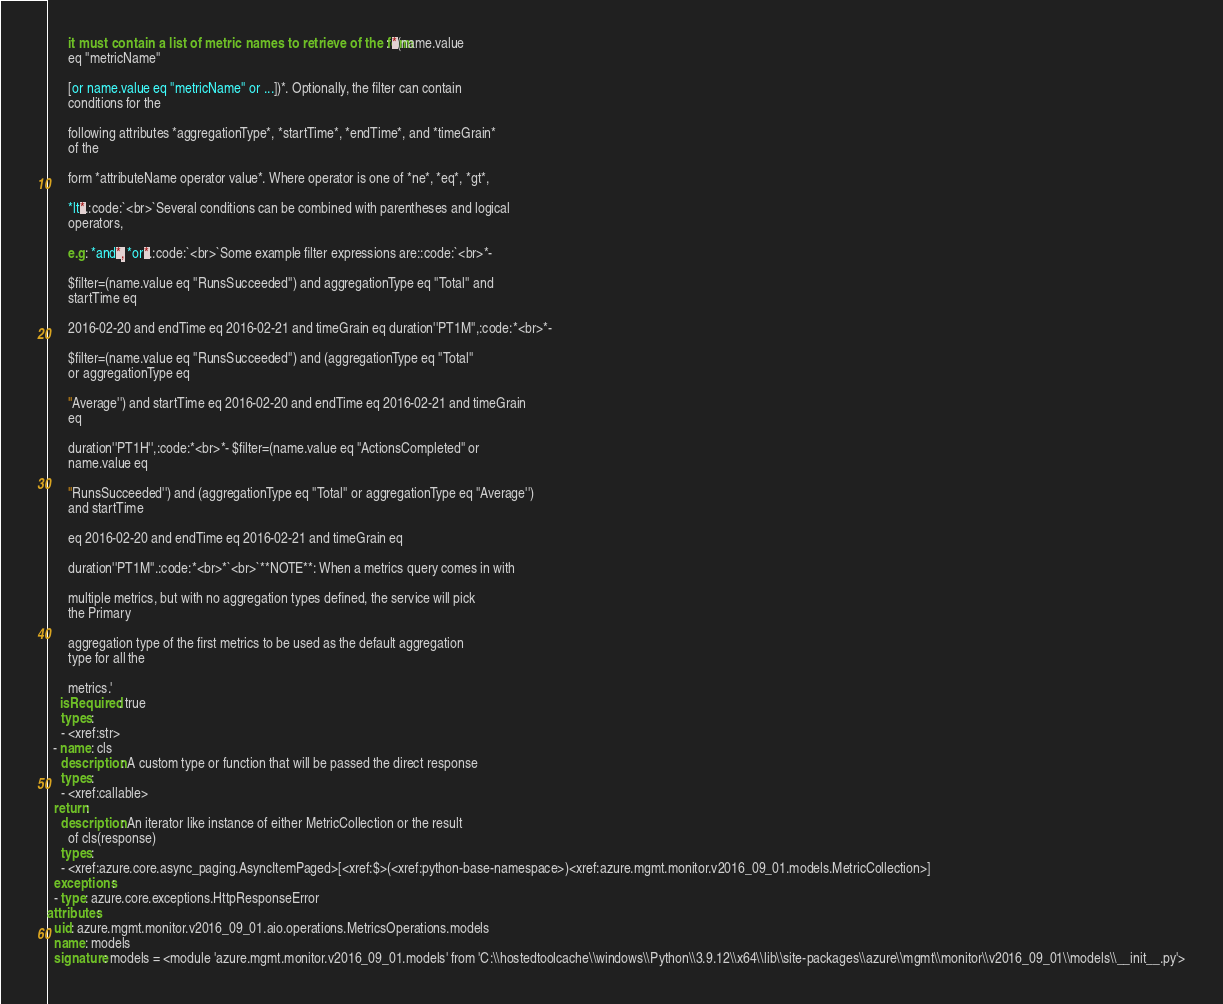Convert code to text. <code><loc_0><loc_0><loc_500><loc_500><_YAML_>      it must contain a list of metric names to retrieve of the form: *(name.value
      eq ''metricName''

      [or name.value eq ''metricName'' or ...])*. Optionally, the filter can contain
      conditions for the

      following attributes *aggregationType*, *startTime*, *endTime*, and *timeGrain*
      of the

      form *attributeName operator value*. Where operator is one of *ne*, *eq*, *gt*,

      *lt*.:code:`<br>`Several conditions can be combined with parentheses and logical
      operators,

      e.g: *and*, *or*.:code:`<br>`Some example filter expressions are::code:`<br>*-

      $filter=(name.value eq ''RunsSucceeded'') and aggregationType eq ''Total'' and
      startTime eq

      2016-02-20 and endTime eq 2016-02-21 and timeGrain eq duration''PT1M'',:code:*<br>*-

      $filter=(name.value eq ''RunsSucceeded'') and (aggregationType eq ''Total''
      or aggregationType eq

      ''Average'') and startTime eq 2016-02-20 and endTime eq 2016-02-21 and timeGrain
      eq

      duration''PT1H'',:code:*<br>*- $filter=(name.value eq ''ActionsCompleted'' or
      name.value eq

      ''RunsSucceeded'') and (aggregationType eq ''Total'' or aggregationType eq ''Average'')
      and startTime

      eq 2016-02-20 and endTime eq 2016-02-21 and timeGrain eq

      duration''PT1M''.:code:*<br>*`<br>`**NOTE**: When a metrics query comes in with

      multiple metrics, but with no aggregation types defined, the service will pick
      the Primary

      aggregation type of the first metrics to be used as the default aggregation
      type for all the

      metrics.'
    isRequired: true
    types:
    - <xref:str>
  - name: cls
    description: A custom type or function that will be passed the direct response
    types:
    - <xref:callable>
  return:
    description: An iterator like instance of either MetricCollection or the result
      of cls(response)
    types:
    - <xref:azure.core.async_paging.AsyncItemPaged>[<xref:$>(<xref:python-base-namespace>)<xref:azure.mgmt.monitor.v2016_09_01.models.MetricCollection>]
  exceptions:
  - type: azure.core.exceptions.HttpResponseError
attributes:
- uid: azure.mgmt.monitor.v2016_09_01.aio.operations.MetricsOperations.models
  name: models
  signature: models = <module 'azure.mgmt.monitor.v2016_09_01.models' from 'C:\\hostedtoolcache\\windows\\Python\\3.9.12\\x64\\lib\\site-packages\\azure\\mgmt\\monitor\\v2016_09_01\\models\\__init__.py'>
</code> 